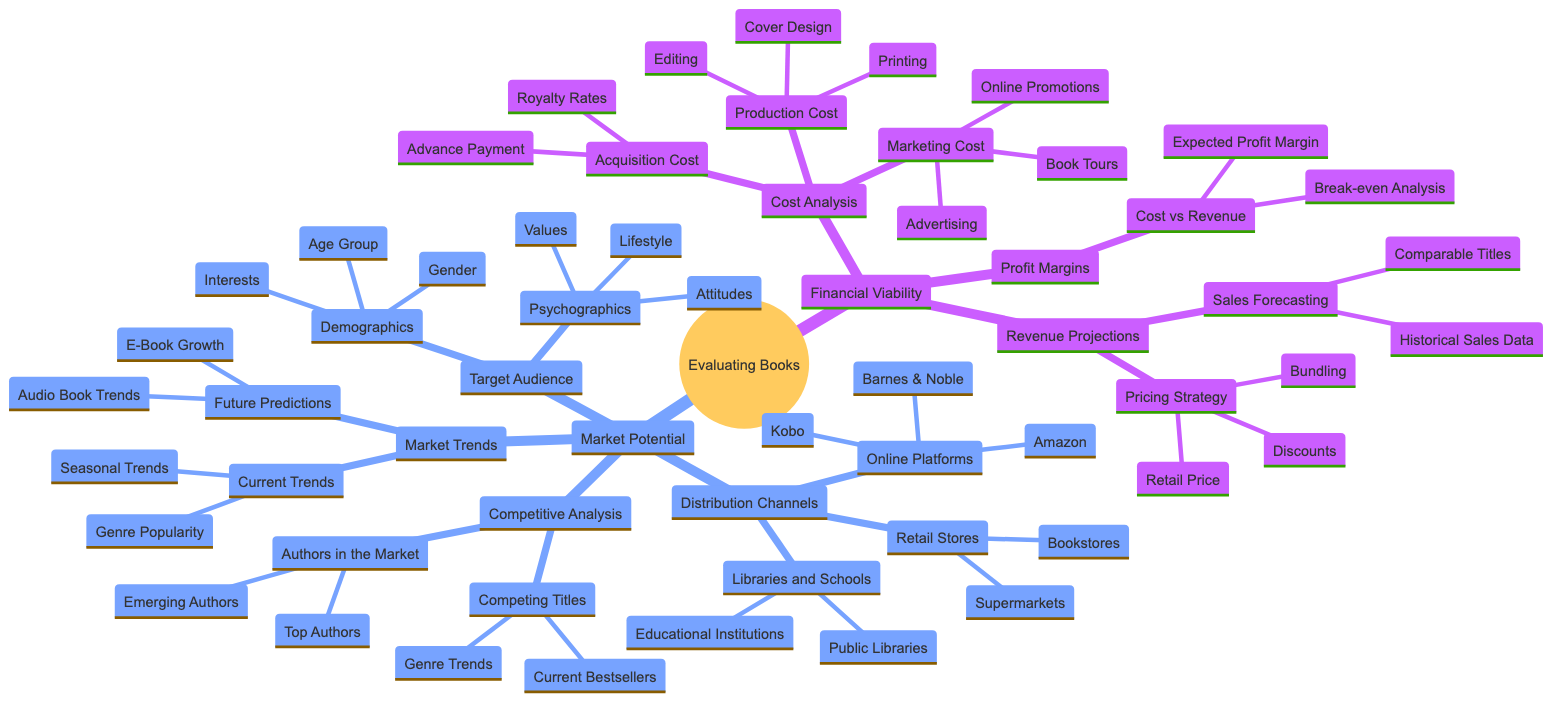What's the primary focus of the diagram? The title of the diagram clearly states "Evaluating the Financial Viability and Market Potential of Prospective Books," indicating that the overall focus is on assessing these two aspects regarding books.
Answer: Evaluating the Financial Viability and Market Potential of Prospective Books What are the components of Cost Analysis under Financial Viability? According to the diagram, the components listed under Cost Analysis are Acquisition Cost, Production Cost, and Marketing Cost.
Answer: Acquisition Cost, Production Cost, Marketing Cost How many subcategories are under Revenue Projections? The diagram shows that Revenue Projections has two subcategories: Sales Forecasting and Pricing Strategy, making it a total of two.
Answer: 2 Which aspect of Market Potential includes Demographics? The diagram categorizes Demographics under Target Audience, suggesting it is a major part of understanding Market Potential.
Answer: Target Audience What kind of trends are indicated under Market Trends? The diagram indicates two types of trends: Current Trends and Future Predictions, highlighting different perspectives on market dynamics.
Answer: Current Trends, Future Predictions How does Break-even Analysis relate to Profit Margins? Break-even Analysis is listed as a part of the Cost vs Revenue section under Profit Margins, demonstrating that it is a critical analytical tool for profitability assessment.
Answer: Cost vs Revenue Which distribution channels are suggested for book sales? The diagram identifies three types of distribution channels: Retail Stores, Online Platforms, and Libraries and Schools.
Answer: Retail Stores, Online Platforms, Libraries and Schools How does Competitive Analysis differ from Market Trends? Competitive Analysis focuses on evaluating existing titles and authors currently in the market, while Market Trends looks at both current and future market dynamics; thus, they serve different evaluative purposes within the larger context.
Answer: Different evaluative purposes What factors influence the Pricing Strategy within Revenue Projections? The Pricing Strategy influences Revenue Projections through Retail Price, Discounts, and Bundling, indicating various methods of price management.
Answer: Retail Price, Discounts, Bundling 